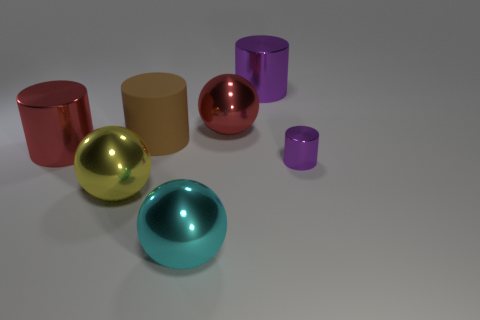Subtract 1 cylinders. How many cylinders are left? 3 Subtract all red cylinders. How many cylinders are left? 3 Subtract all shiny cylinders. How many cylinders are left? 1 Subtract all blue cylinders. Subtract all red balls. How many cylinders are left? 4 Add 2 tiny metallic cylinders. How many objects exist? 9 Subtract all cylinders. How many objects are left? 3 Subtract all large red things. Subtract all cyan metal objects. How many objects are left? 4 Add 2 small metallic things. How many small metallic things are left? 3 Add 7 metal cylinders. How many metal cylinders exist? 10 Subtract 0 blue spheres. How many objects are left? 7 